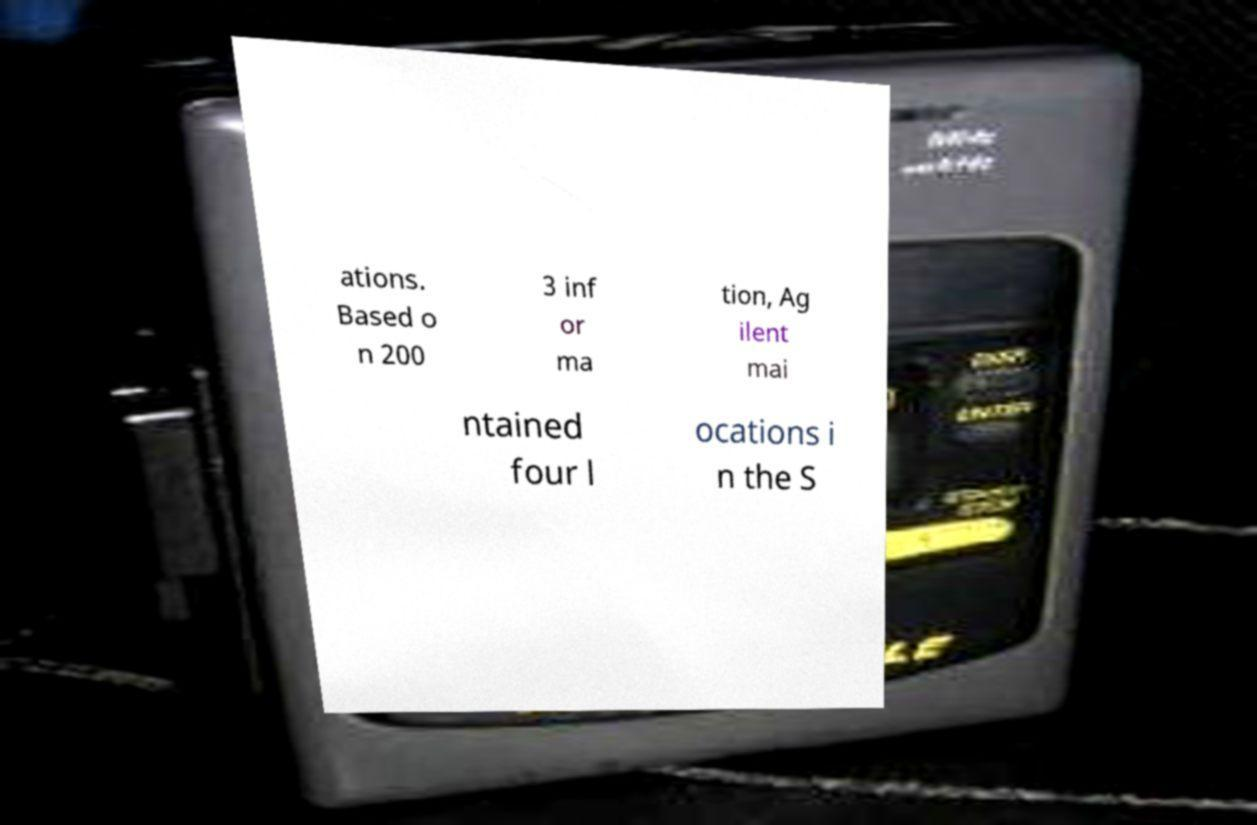Could you assist in decoding the text presented in this image and type it out clearly? ations. Based o n 200 3 inf or ma tion, Ag ilent mai ntained four l ocations i n the S 